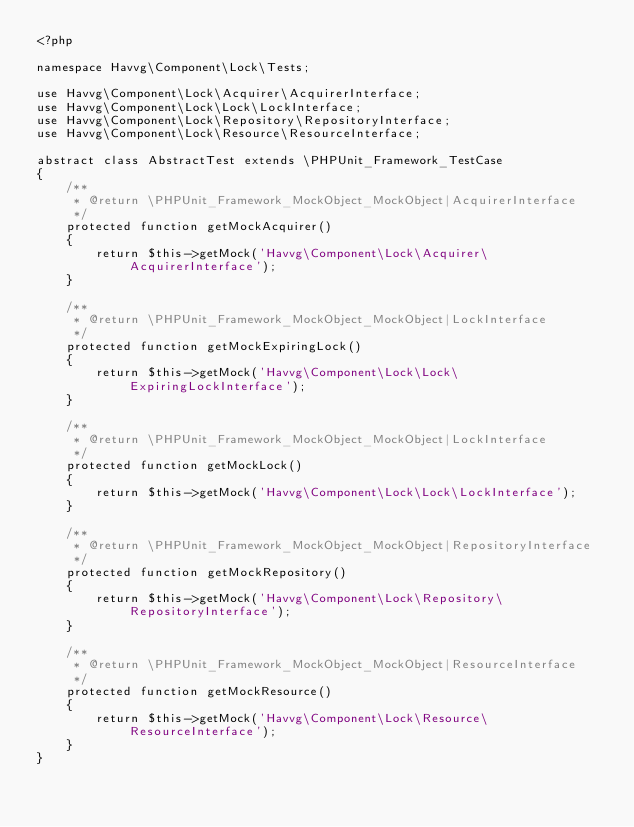Convert code to text. <code><loc_0><loc_0><loc_500><loc_500><_PHP_><?php

namespace Havvg\Component\Lock\Tests;

use Havvg\Component\Lock\Acquirer\AcquirerInterface;
use Havvg\Component\Lock\Lock\LockInterface;
use Havvg\Component\Lock\Repository\RepositoryInterface;
use Havvg\Component\Lock\Resource\ResourceInterface;

abstract class AbstractTest extends \PHPUnit_Framework_TestCase
{
    /**
     * @return \PHPUnit_Framework_MockObject_MockObject|AcquirerInterface
     */
    protected function getMockAcquirer()
    {
        return $this->getMock('Havvg\Component\Lock\Acquirer\AcquirerInterface');
    }

    /**
     * @return \PHPUnit_Framework_MockObject_MockObject|LockInterface
     */
    protected function getMockExpiringLock()
    {
        return $this->getMock('Havvg\Component\Lock\Lock\ExpiringLockInterface');
    }

    /**
     * @return \PHPUnit_Framework_MockObject_MockObject|LockInterface
     */
    protected function getMockLock()
    {
        return $this->getMock('Havvg\Component\Lock\Lock\LockInterface');
    }

    /**
     * @return \PHPUnit_Framework_MockObject_MockObject|RepositoryInterface
     */
    protected function getMockRepository()
    {
        return $this->getMock('Havvg\Component\Lock\Repository\RepositoryInterface');
    }

    /**
     * @return \PHPUnit_Framework_MockObject_MockObject|ResourceInterface
     */
    protected function getMockResource()
    {
        return $this->getMock('Havvg\Component\Lock\Resource\ResourceInterface');
    }
}
</code> 